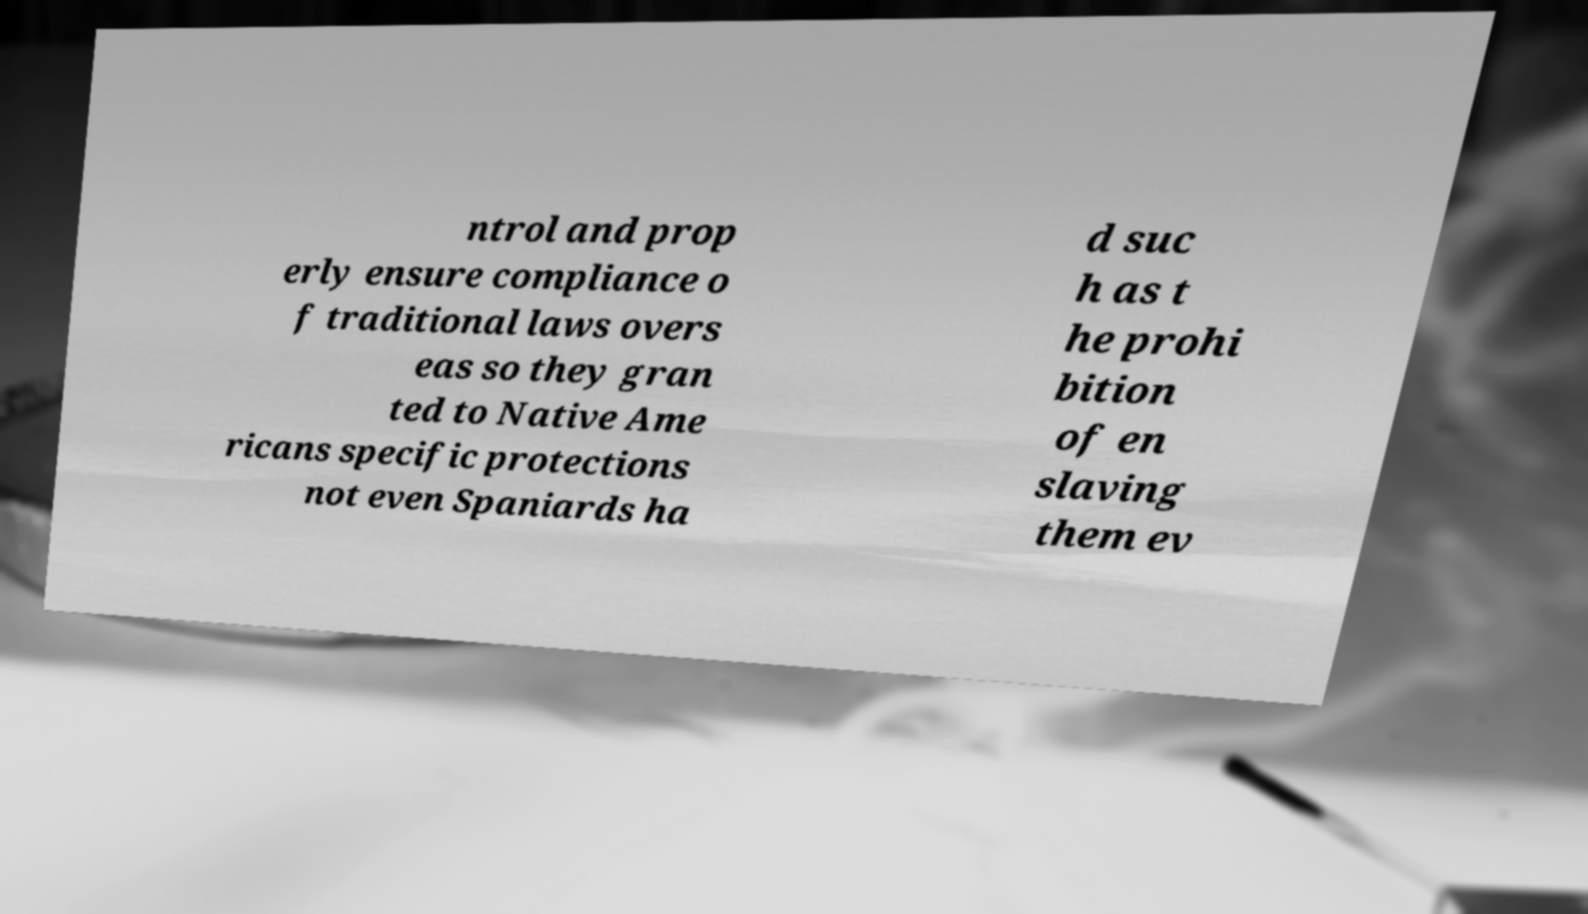What messages or text are displayed in this image? I need them in a readable, typed format. ntrol and prop erly ensure compliance o f traditional laws overs eas so they gran ted to Native Ame ricans specific protections not even Spaniards ha d suc h as t he prohi bition of en slaving them ev 